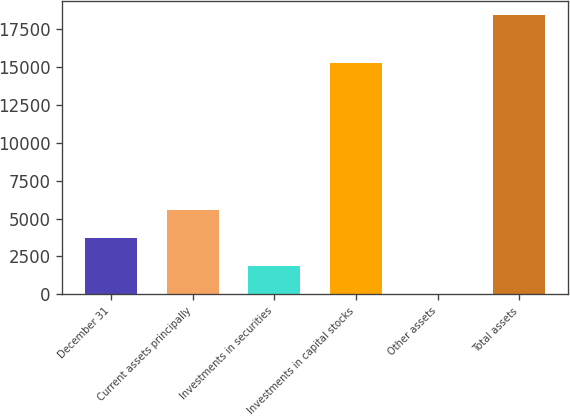Convert chart to OTSL. <chart><loc_0><loc_0><loc_500><loc_500><bar_chart><fcel>December 31<fcel>Current assets principally<fcel>Investments in securities<fcel>Investments in capital stocks<fcel>Other assets<fcel>Total assets<nl><fcel>3703<fcel>5545<fcel>1861<fcel>15276<fcel>19<fcel>18439<nl></chart> 